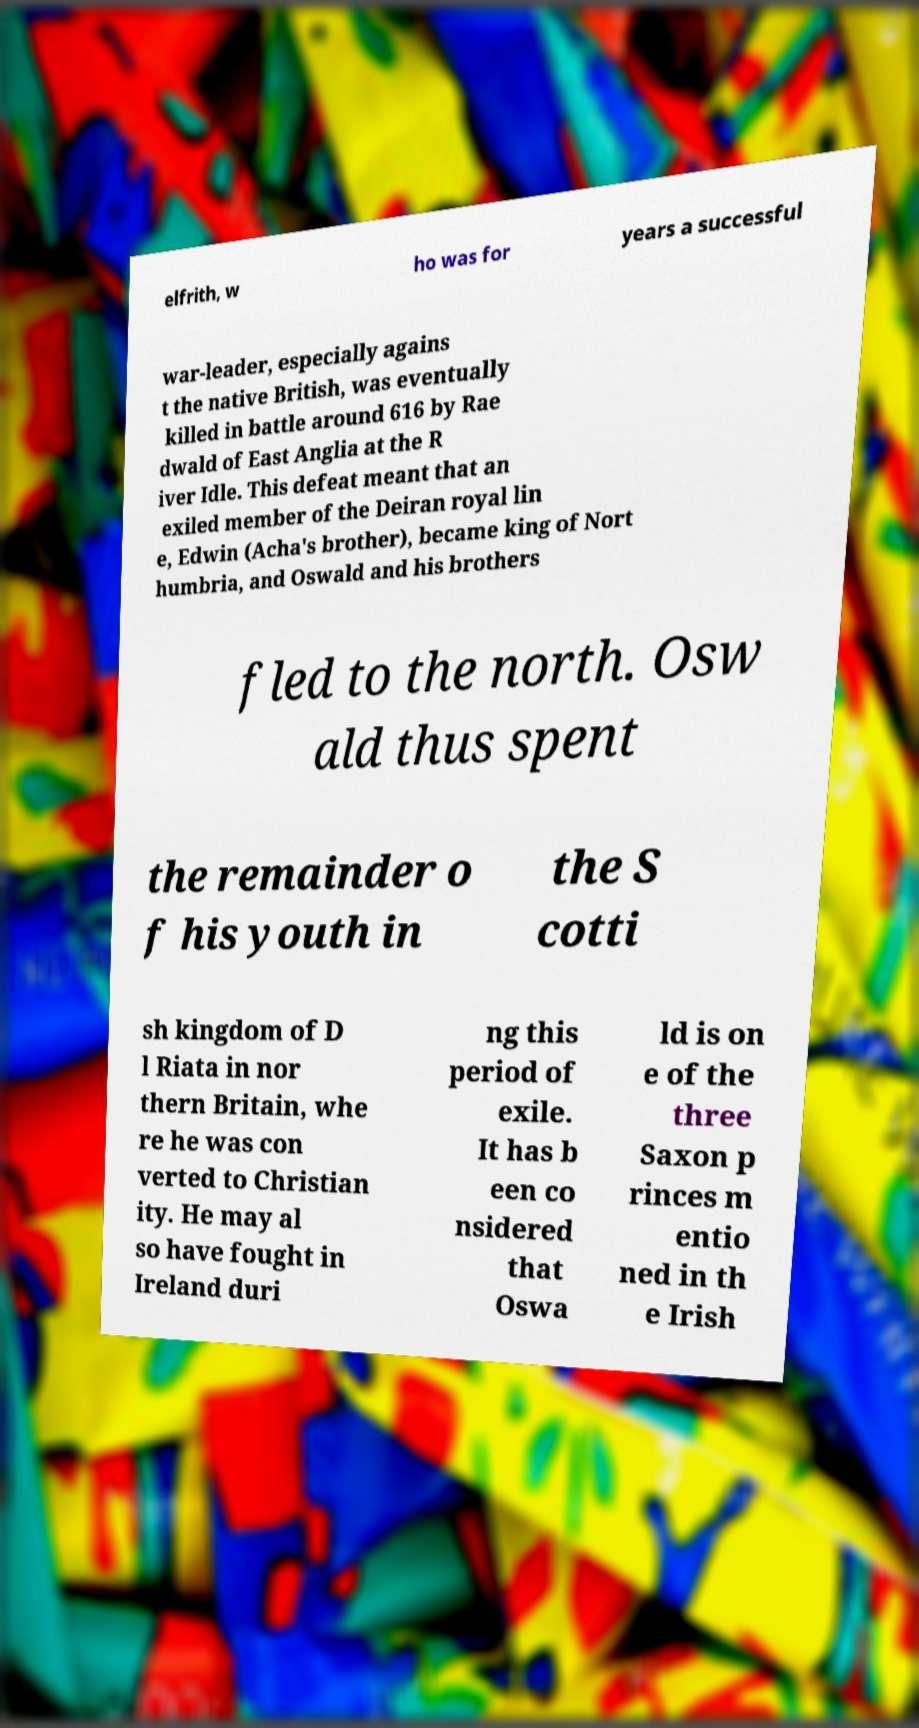Could you assist in decoding the text presented in this image and type it out clearly? elfrith, w ho was for years a successful war-leader, especially agains t the native British, was eventually killed in battle around 616 by Rae dwald of East Anglia at the R iver Idle. This defeat meant that an exiled member of the Deiran royal lin e, Edwin (Acha's brother), became king of Nort humbria, and Oswald and his brothers fled to the north. Osw ald thus spent the remainder o f his youth in the S cotti sh kingdom of D l Riata in nor thern Britain, whe re he was con verted to Christian ity. He may al so have fought in Ireland duri ng this period of exile. It has b een co nsidered that Oswa ld is on e of the three Saxon p rinces m entio ned in th e Irish 